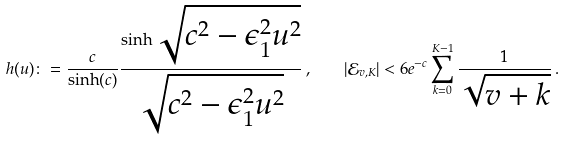Convert formula to latex. <formula><loc_0><loc_0><loc_500><loc_500>h ( u ) \colon = \frac { c } { \sinh ( c ) } \frac { \sinh \sqrt { c ^ { 2 } - \epsilon _ { 1 } ^ { 2 } u ^ { 2 } } } { \sqrt { c ^ { 2 } - \epsilon _ { 1 } ^ { 2 } u ^ { 2 } } } \, , \quad | \mathcal { E } _ { v , K } | < 6 e ^ { - c } \sum _ { k = 0 } ^ { K - 1 } \frac { 1 } { \sqrt { v + k } } \, .</formula> 